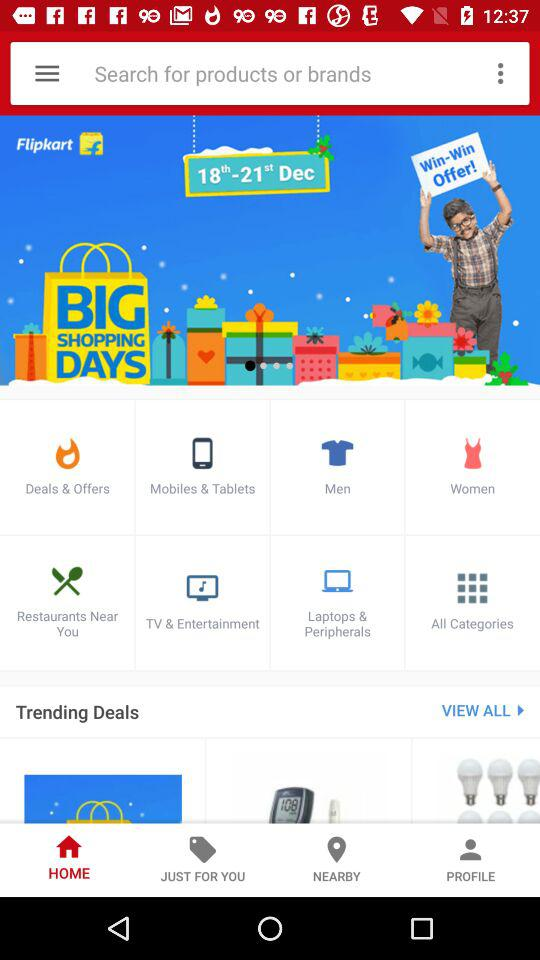What will be the date of the big shopping days? The dates of the big shopping days will be from December 18th to December 21st. 